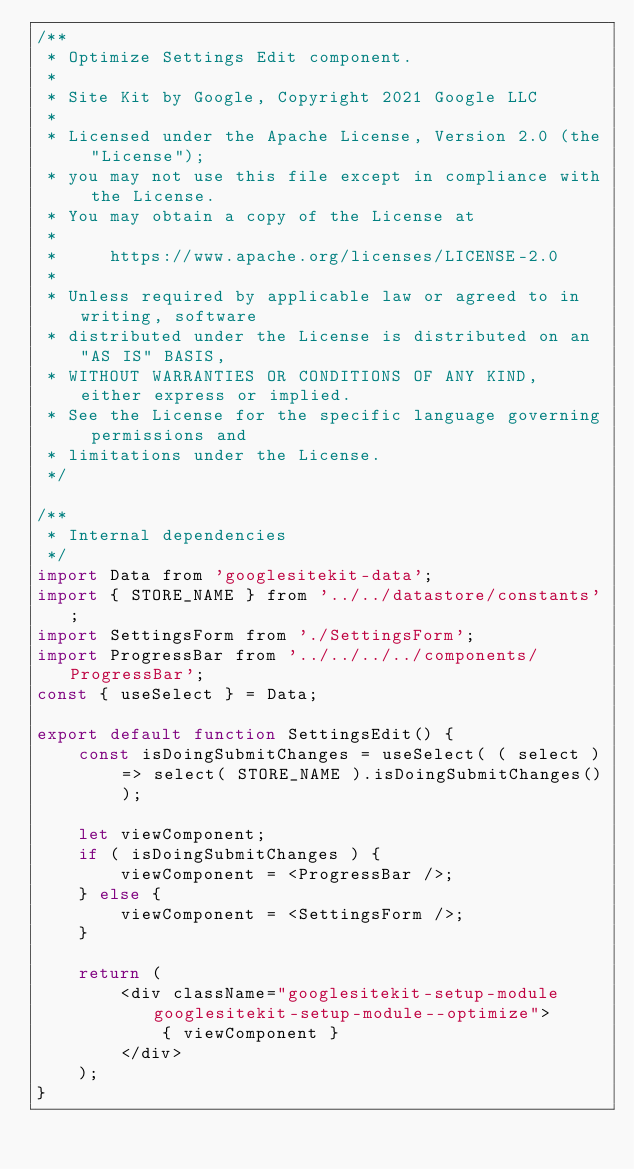Convert code to text. <code><loc_0><loc_0><loc_500><loc_500><_JavaScript_>/**
 * Optimize Settings Edit component.
 *
 * Site Kit by Google, Copyright 2021 Google LLC
 *
 * Licensed under the Apache License, Version 2.0 (the "License");
 * you may not use this file except in compliance with the License.
 * You may obtain a copy of the License at
 *
 *     https://www.apache.org/licenses/LICENSE-2.0
 *
 * Unless required by applicable law or agreed to in writing, software
 * distributed under the License is distributed on an "AS IS" BASIS,
 * WITHOUT WARRANTIES OR CONDITIONS OF ANY KIND, either express or implied.
 * See the License for the specific language governing permissions and
 * limitations under the License.
 */

/**
 * Internal dependencies
 */
import Data from 'googlesitekit-data';
import { STORE_NAME } from '../../datastore/constants';
import SettingsForm from './SettingsForm';
import ProgressBar from '../../../../components/ProgressBar';
const { useSelect } = Data;

export default function SettingsEdit() {
	const isDoingSubmitChanges = useSelect( ( select ) => select( STORE_NAME ).isDoingSubmitChanges() );

	let viewComponent;
	if ( isDoingSubmitChanges ) {
		viewComponent = <ProgressBar />;
	} else {
		viewComponent = <SettingsForm />;
	}

	return (
		<div className="googlesitekit-setup-module googlesitekit-setup-module--optimize">
			{ viewComponent }
		</div>
	);
}
</code> 